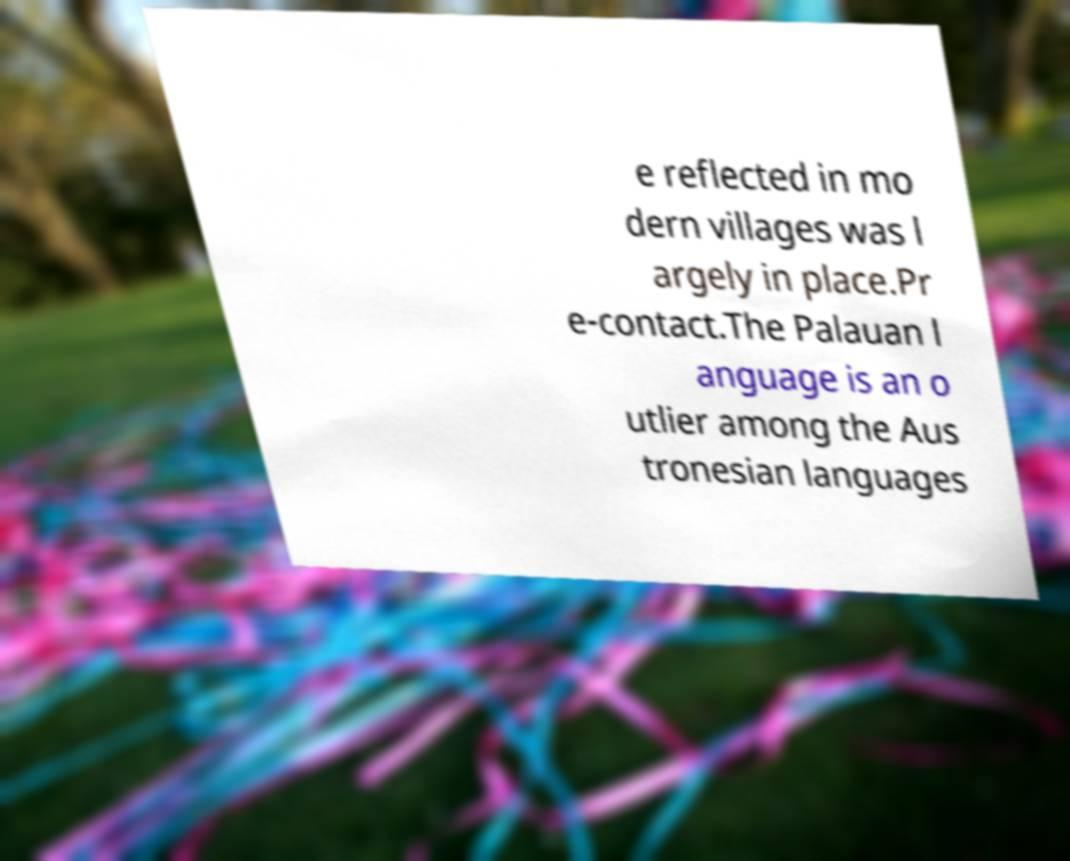For documentation purposes, I need the text within this image transcribed. Could you provide that? e reflected in mo dern villages was l argely in place.Pr e-contact.The Palauan l anguage is an o utlier among the Aus tronesian languages 